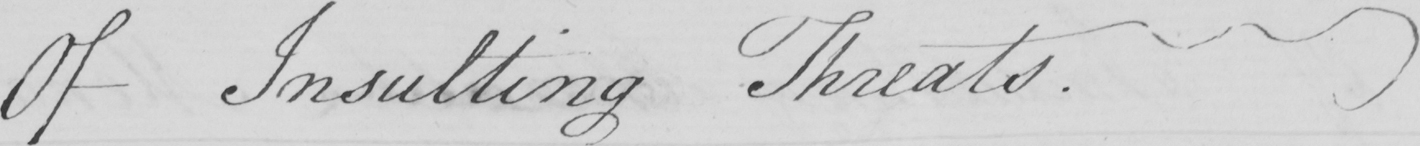Please transcribe the handwritten text in this image. Of Insulting Threats . 